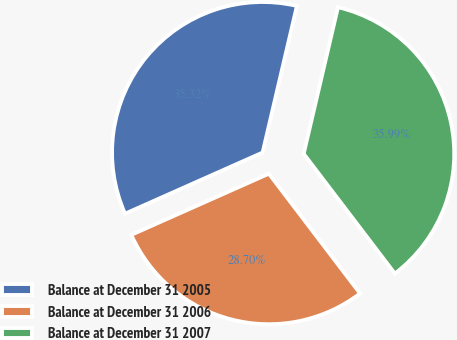Convert chart to OTSL. <chart><loc_0><loc_0><loc_500><loc_500><pie_chart><fcel>Balance at December 31 2005<fcel>Balance at December 31 2006<fcel>Balance at December 31 2007<nl><fcel>35.32%<fcel>28.7%<fcel>35.99%<nl></chart> 